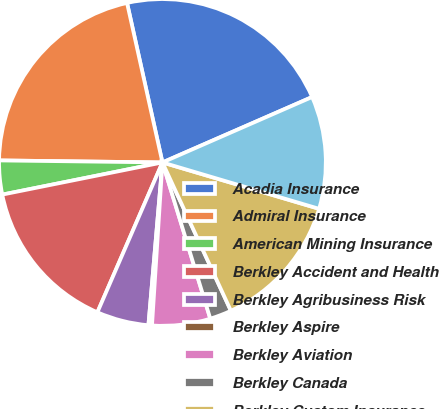Convert chart to OTSL. <chart><loc_0><loc_0><loc_500><loc_500><pie_chart><fcel>Acadia Insurance<fcel>Admiral Insurance<fcel>American Mining Insurance<fcel>Berkley Accident and Health<fcel>Berkley Agribusiness Risk<fcel>Berkley Aspire<fcel>Berkley Aviation<fcel>Berkley Canada<fcel>Berkley Custom Insurance<fcel>Berkley Entertainment<nl><fcel>21.92%<fcel>21.33%<fcel>3.35%<fcel>15.33%<fcel>5.15%<fcel>0.35%<fcel>5.75%<fcel>2.15%<fcel>13.54%<fcel>11.14%<nl></chart> 